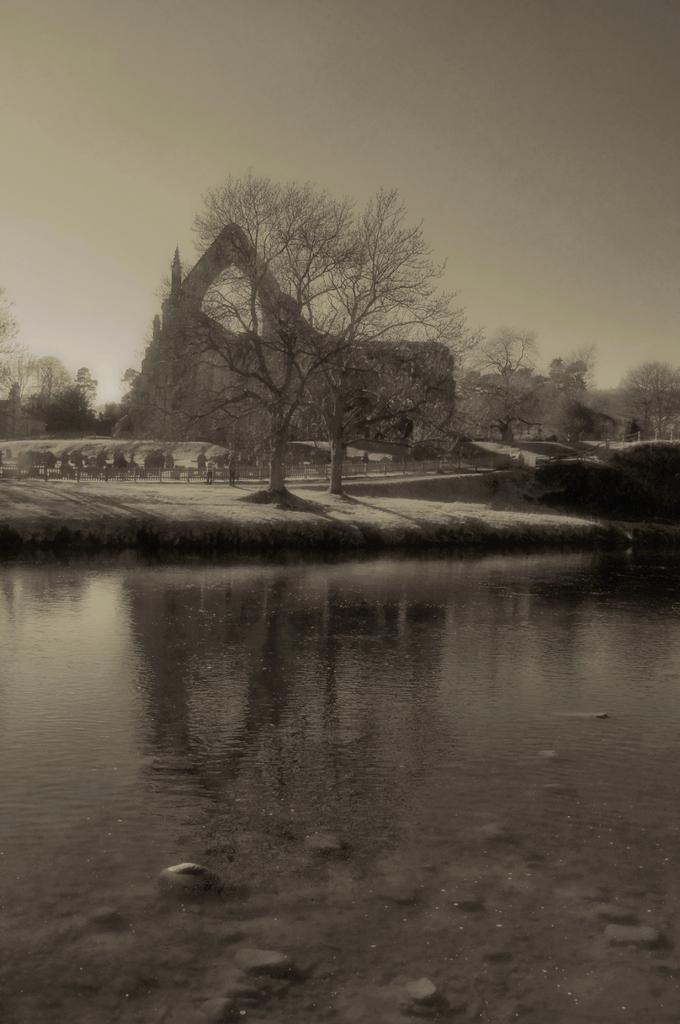What is the color scheme of the image? The image is black and white. What natural feature can be seen in the image? There is a water body in the image. What man-made structure is present in the image? There is a fence in the image. How many people are visible in the image? There are people standing in the image. What type of vegetation is present in the image? There is a group of trees in the image. What type of buildings can be seen in the image? There are houses in the image. What is the condition of the sky in the image? The sky is visible in the image and appears cloudy. How many cows are visible in the image? There are no cows present in the image. What type of paint is used to create the image? The image is black and white, so there is no paint used; it is likely a photograph or a drawing with black and white media. 